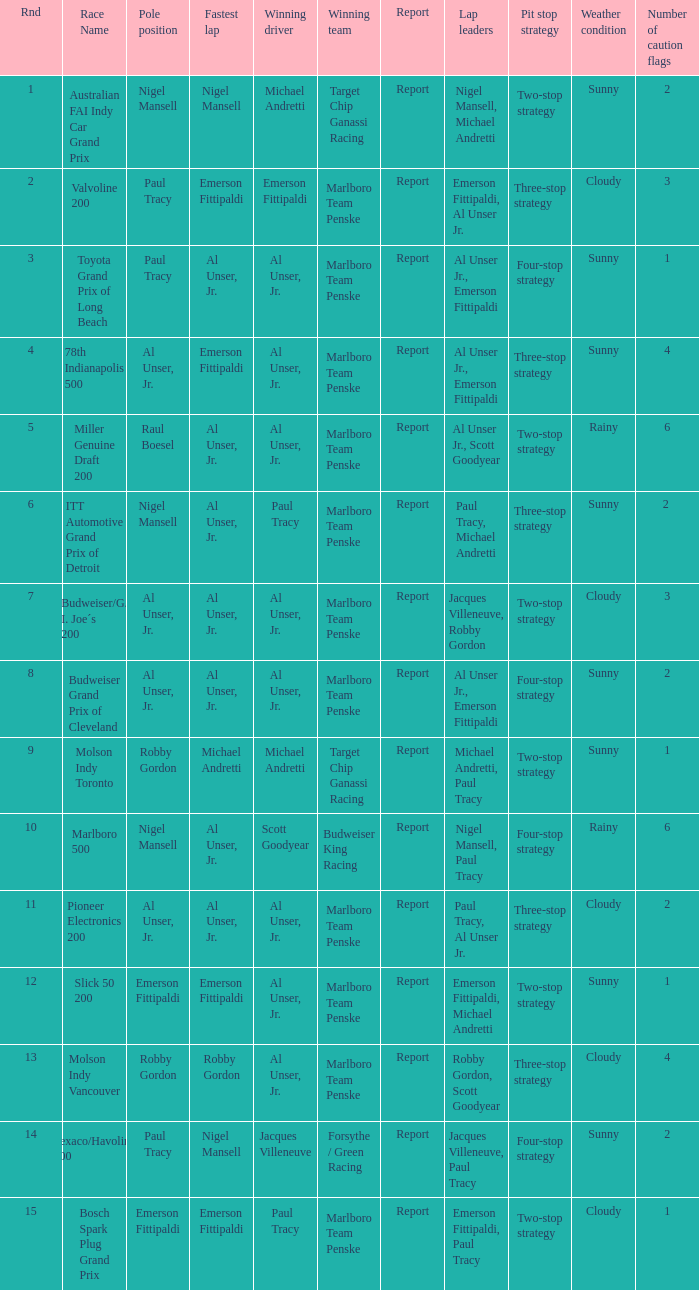Who did the fastest lap in the race won by Paul Tracy, with Emerson Fittipaldi at the pole position? Emerson Fittipaldi. 